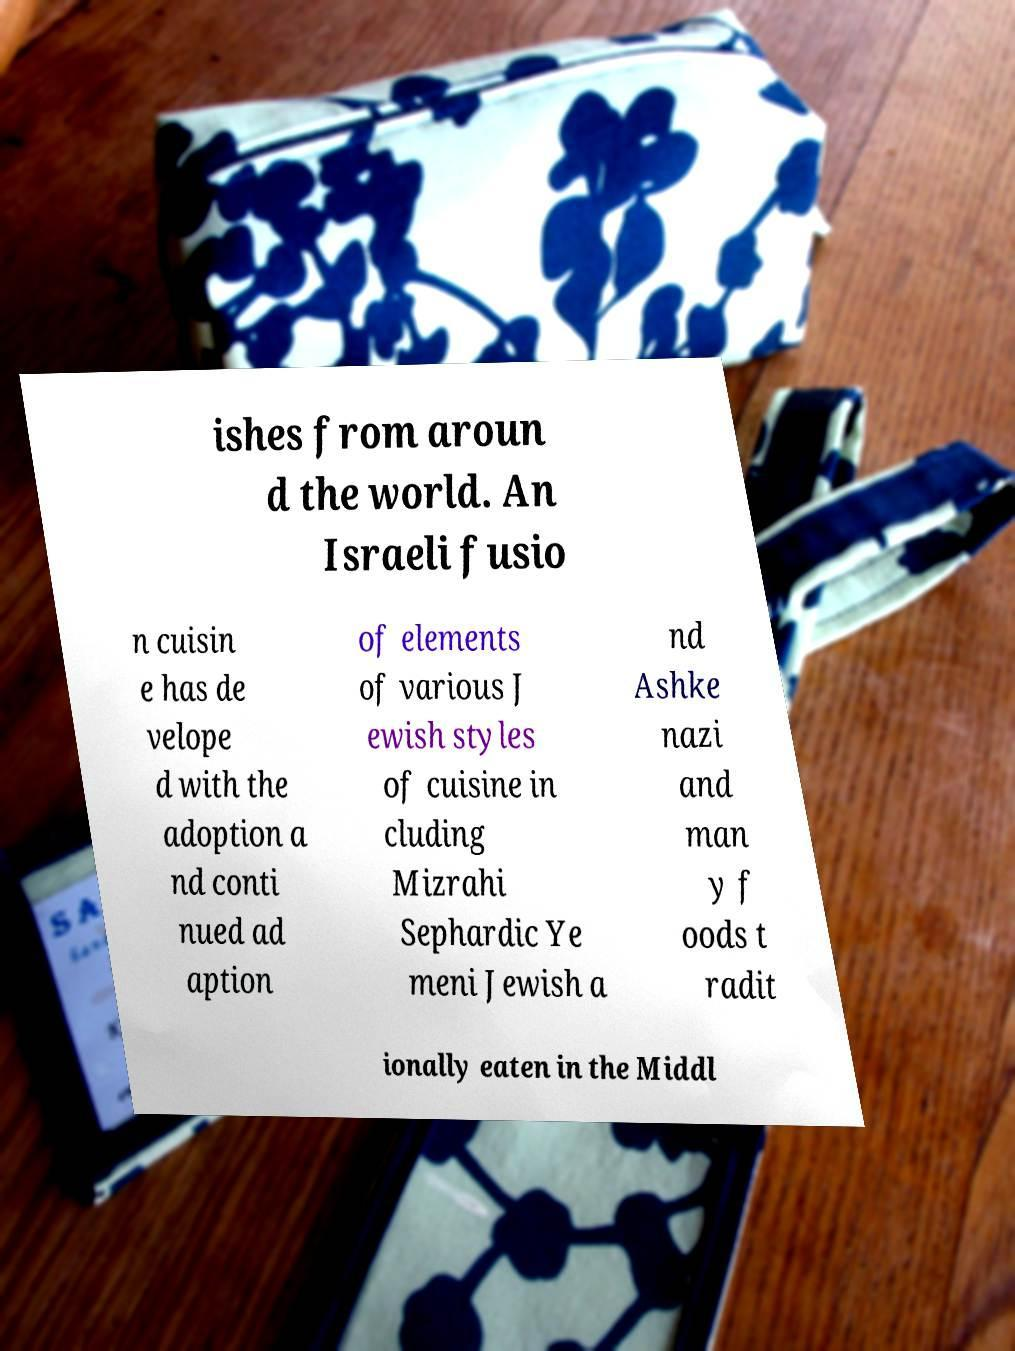Could you extract and type out the text from this image? ishes from aroun d the world. An Israeli fusio n cuisin e has de velope d with the adoption a nd conti nued ad aption of elements of various J ewish styles of cuisine in cluding Mizrahi Sephardic Ye meni Jewish a nd Ashke nazi and man y f oods t radit ionally eaten in the Middl 